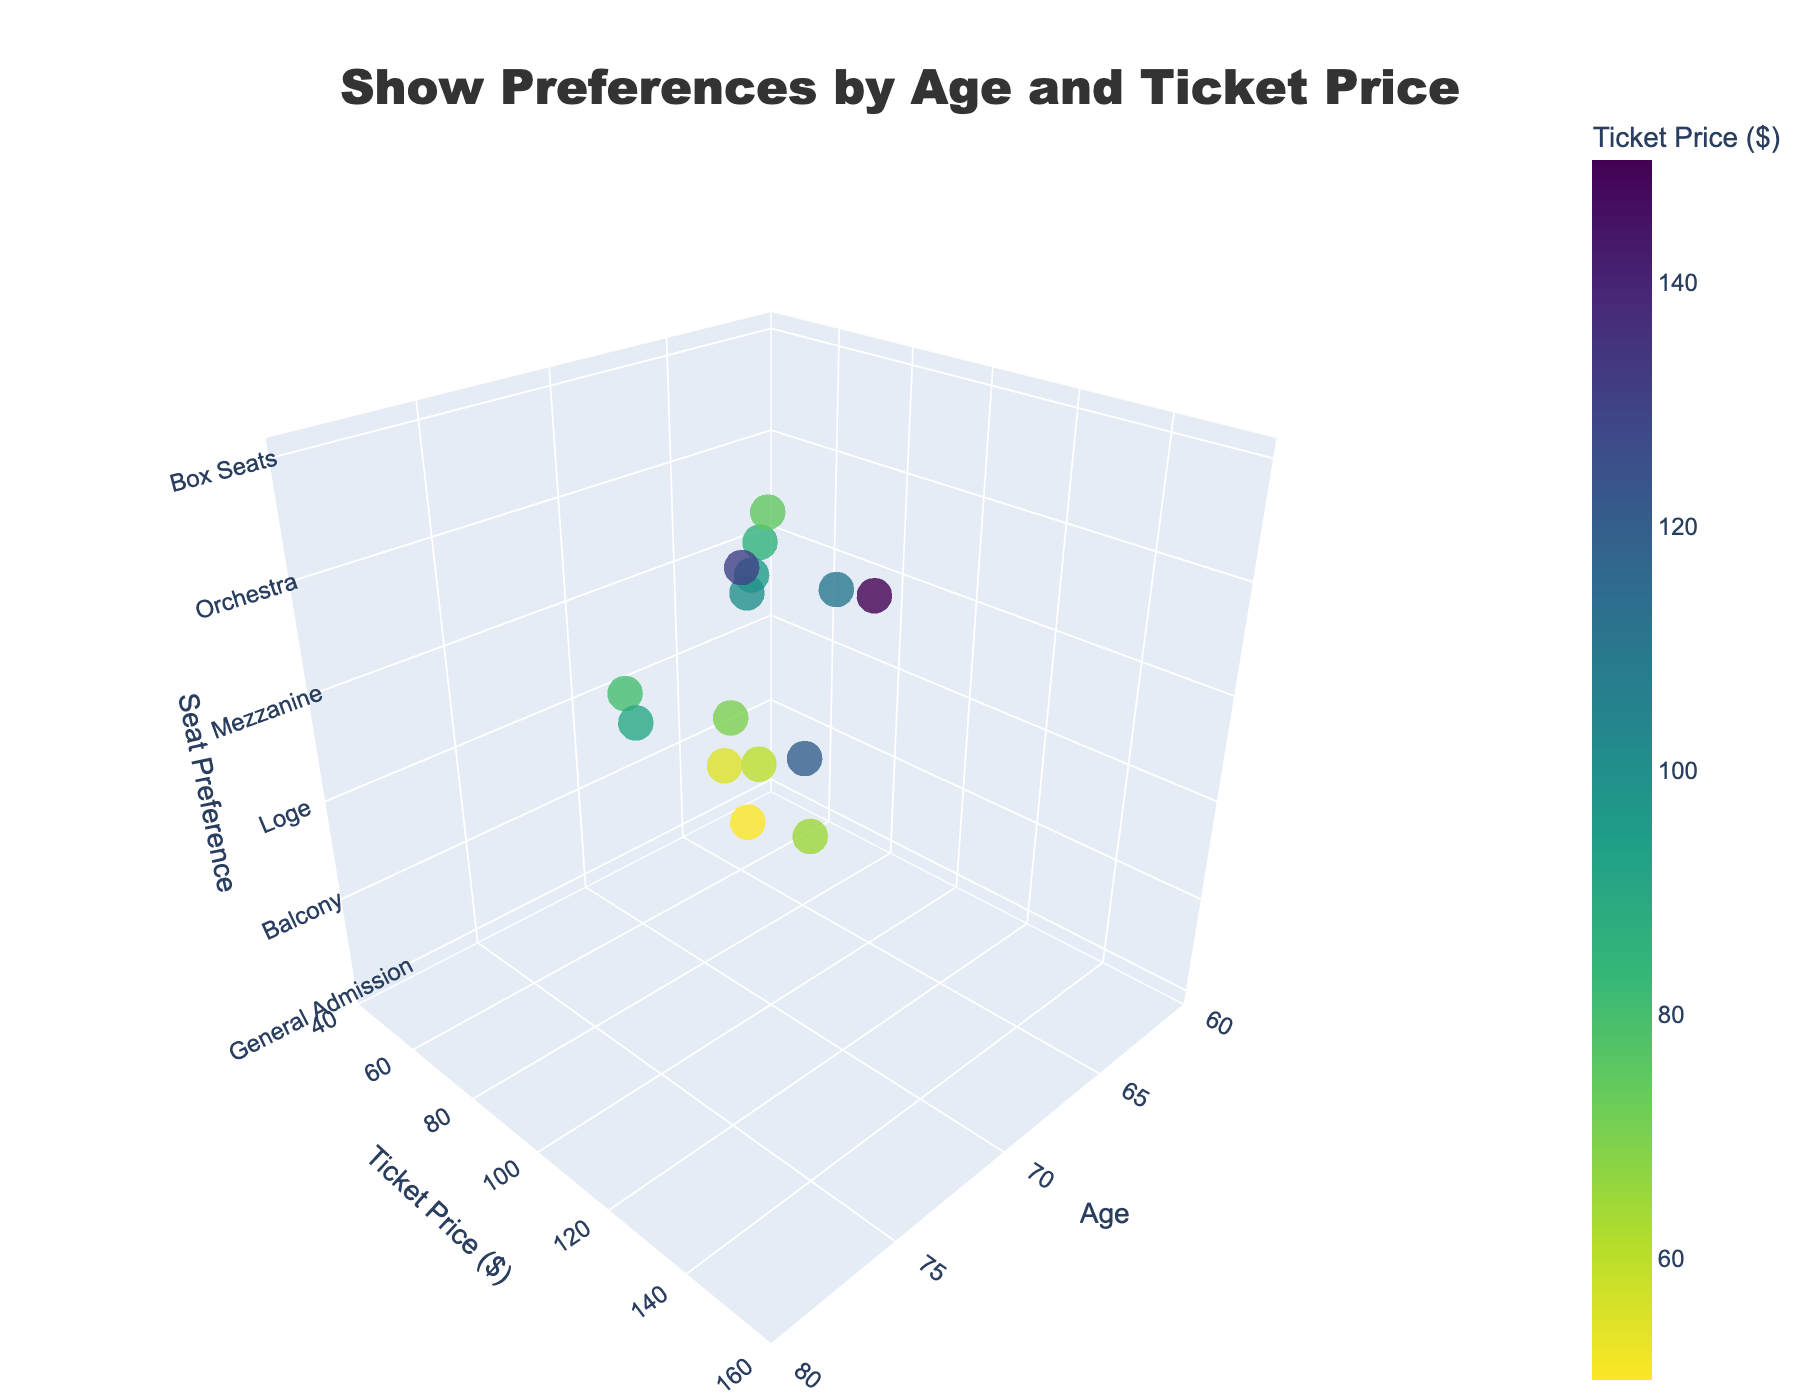How many different types of shows are represented in the plot? Look at the plotted points and hover over them to see the "ShowType" label. Count the unique show types.
Answer: 12 Which age group tends to prefer "Box Seats"? Identify the points labeled "Box Seats" in the z-axis and then check their corresponding "Age" values on the x-axis.
Answer: 75, 76 Which show type has the highest ticket price? Hover over the points to see the "Ticket Price" values and note the show type associated with the highest price.
Answer: Ballet What's the range of ticket prices for "Orchestra" seat preferences? Locate all points with "Orchestra" on the z-axis, then note the lowest and highest "Ticket Price" values on the y-axis.
Answer: 75 to 110 dollars What's the average age of people attending "Broadway Musical"? Find the point labeled "Broadway Musical," note the age, and as there is only one point, that is the average.
Answer: 68 Which show type is preferred by the youngest group? Find the lowest point on the x-axis, note the "ShowType" label for the corresponding point.
Answer: Local Theater Production What is the age difference between the oldest and youngest attendees of "Comedy Show"? Find the points labeled "Comedy Show," note their "Age" values, then subtract the youngest age from the oldest age.
Answer: 65 - 64 = 1 year How do ticket prices compare for "Orchestra" vs. "Mezzanine" seats? Note the ticket prices for all points labeled "Orchestra" and "Mezzanine" on the z-axis and compare the range.
Answer: Orchestra: 75 to 110 dollars, Mezzanine: 80 to 120 dollars Which show type has the most affordable ticket prices? Locate the points with the lowest "Ticket Price" values and find their corresponding "ShowType" labels.
Answer: Local Theater Production What is the correlation between age and ticket price for "Jazz Performance"? Identify the point for "Jazz Performance," then note the age and ticket price. Since there's only one point, a direct correlation cannot be established without further data.
Answer: Single data point, no clear correlation 